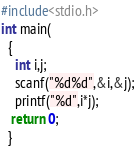<code> <loc_0><loc_0><loc_500><loc_500><_C_>#include<stdio.h>
int main(
  {
    int i,j;
    scanf("%d%d",&i,&j);
    printf("%d",i*j);
   return 0; 
  }</code> 